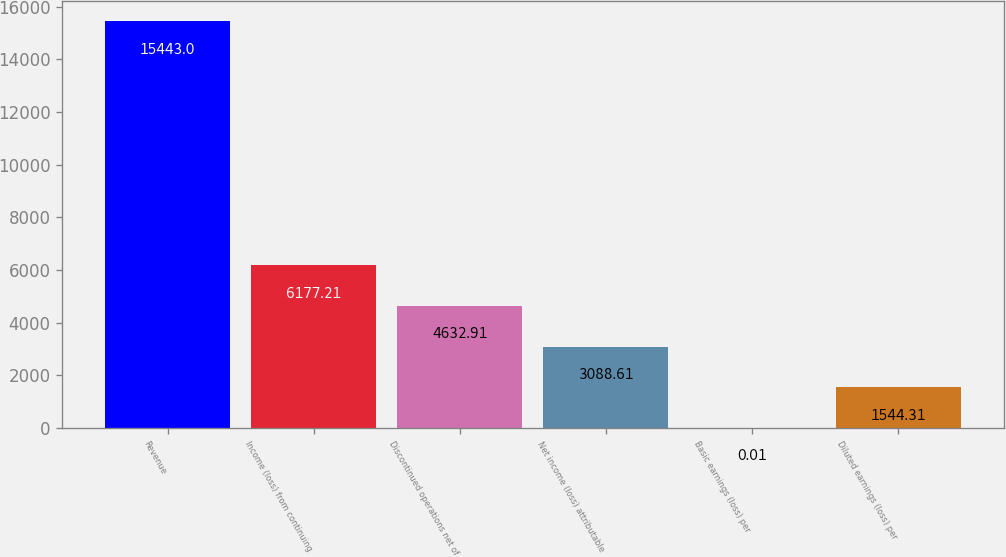Convert chart to OTSL. <chart><loc_0><loc_0><loc_500><loc_500><bar_chart><fcel>Revenue<fcel>Income (loss) from continuing<fcel>Discontinued operations net of<fcel>Net income (loss) attributable<fcel>Basic earnings (loss) per<fcel>Diluted earnings (loss) per<nl><fcel>15443<fcel>6177.21<fcel>4632.91<fcel>3088.61<fcel>0.01<fcel>1544.31<nl></chart> 